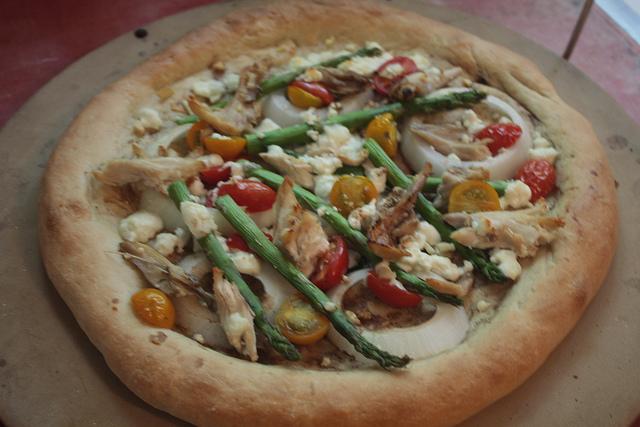Is the pizza whole?
Give a very brief answer. Yes. Is this finger food?
Quick response, please. Yes. Can any of these ingredients be grown in a garden?
Keep it brief. Yes. 